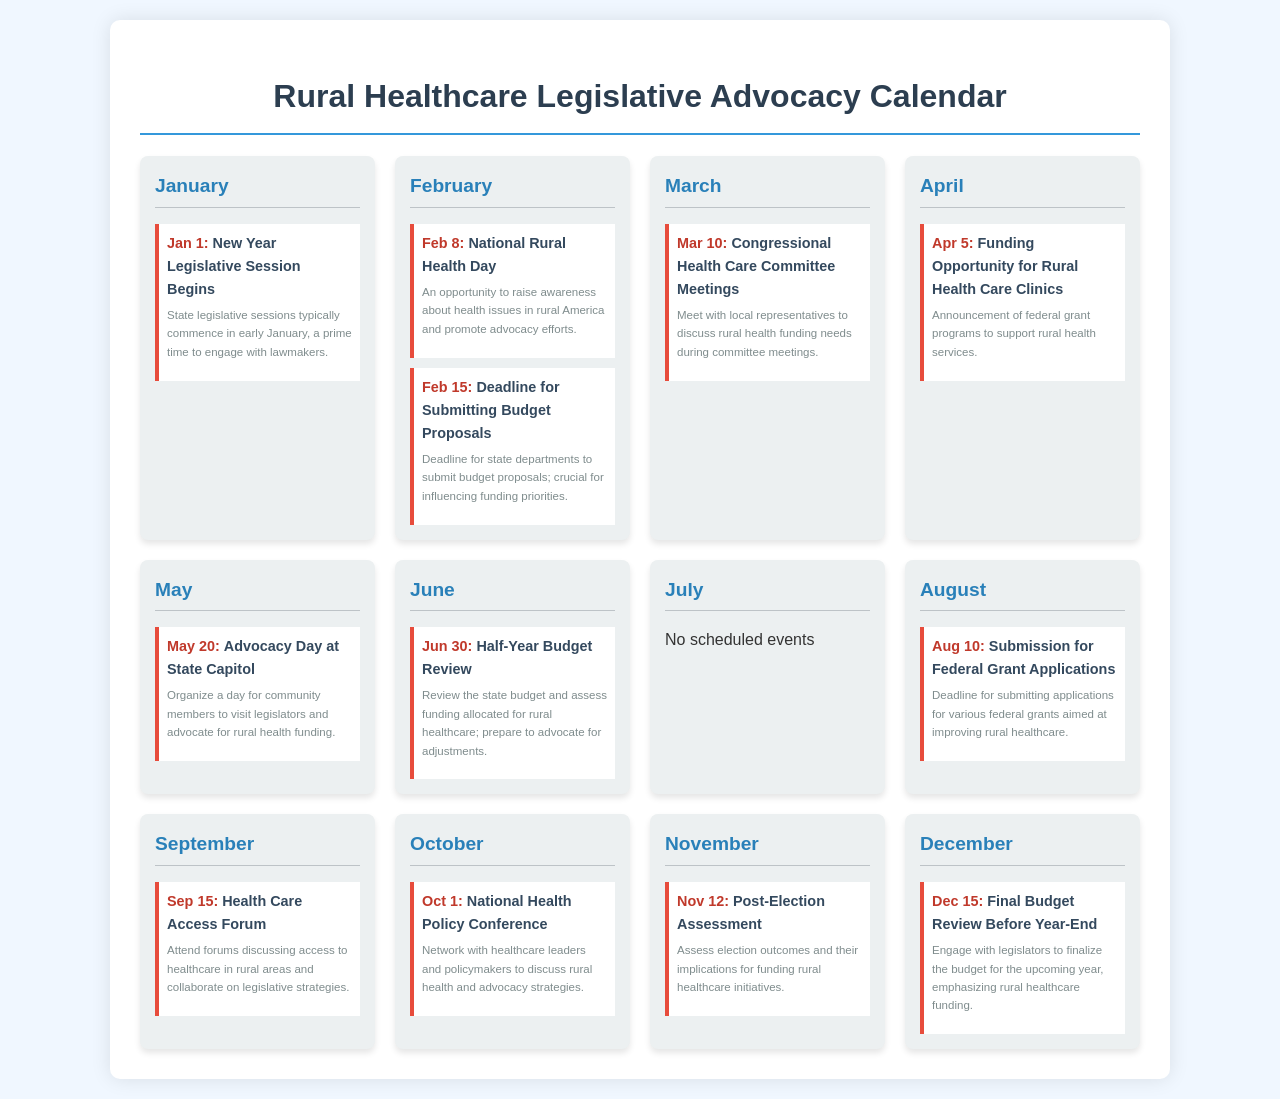What is the date for National Rural Health Day? National Rural Health Day is scheduled for February 8.
Answer: February 8 What significant event happens on April 5? April 5 is the announcement date for federal grant programs to support rural health services.
Answer: Funding Opportunity for Rural Health Care Clinics What is the focus of the Health Care Access Forum in September? The Health Care Access Forum discusses access to healthcare in rural areas and collaborative legislative strategies.
Answer: Healthcare access in rural areas When is the deadline for submitting budget proposals? The deadline for budget proposals is on February 15.
Answer: February 15 What event takes place on October 1? On October 1, the National Health Policy Conference occurs, focusing on rural health and advocacy strategies.
Answer: National Health Policy Conference How many months have scheduled events? There are scheduled events in nine months.
Answer: Nine months What is the purpose of the Advocacy Day at the State Capitol? The purpose of the Advocacy Day is for community members to visit legislators and advocate for rural health funding.
Answer: Advocate for rural health funding What month has no scheduled events? July has no scheduled events.
Answer: July 